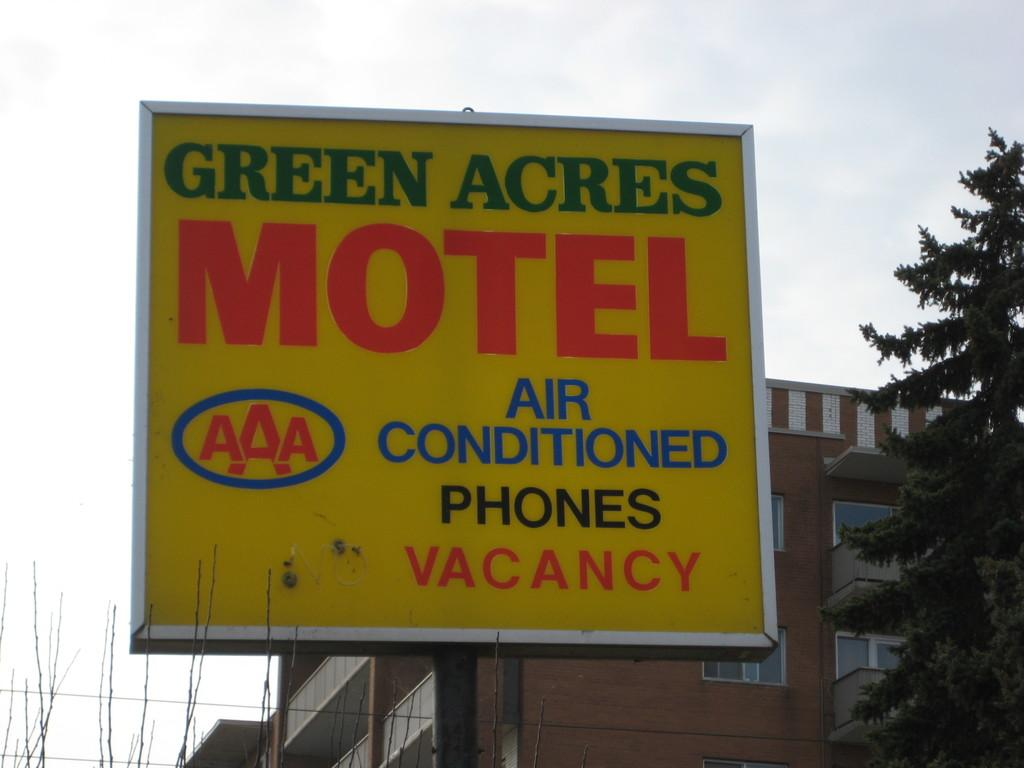Provide a one-sentence caption for the provided image. a sign with the word motel on it outside. 